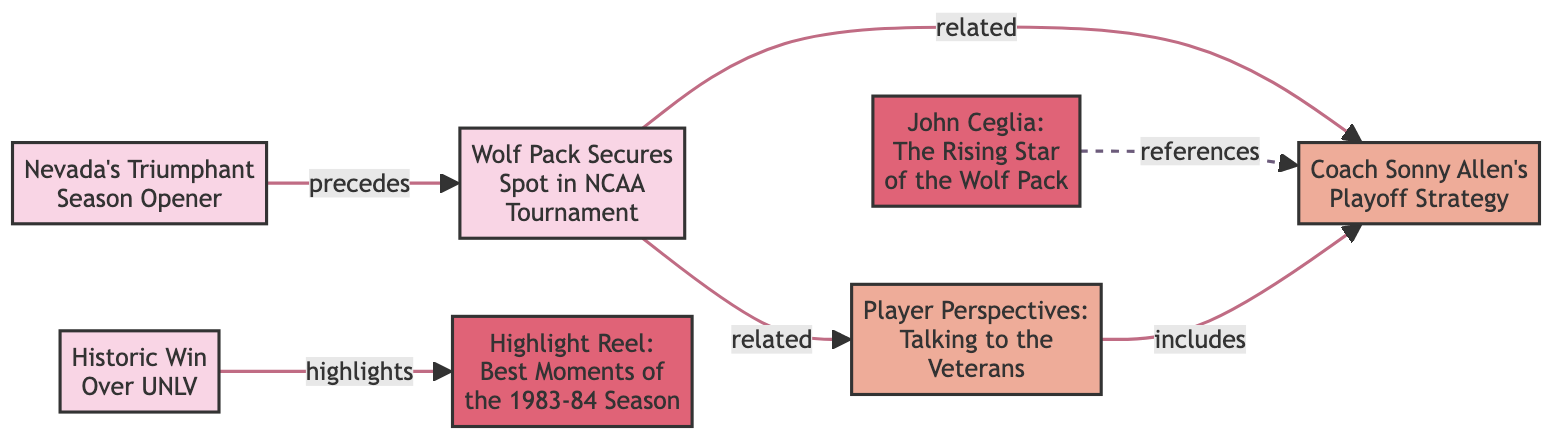What is the title of the feature related to John Ceglia? Looking at the diagram, the node labeled "John Ceglia: The Rising Star of the Wolf Pack" represents a feature. Therefore, this is the title of the feature connected to John Ceglia.
Answer: John Ceglia: The Rising Star of the Wolf Pack Which article precedes the one about the Wolf Pack's NCAA Tournament spot? The edge connecting the node for "Nevada's Triumphant Season Opener" (1) to "Wolf Pack Secures Spot in NCAA Tournament" (2) indicates a "precedes" relationship, meaning node 1 is the article before node 2.
Answer: Nevada's Triumphant Season Opener How many nodes are there in the diagram? Counting the number of nodes listed at the start, we see there are seven nodes in total: three articles, two features, and two interviews. Thus, the total count is seven.
Answer: 7 What type of media is "Coach Sonny Allen's Playoff Strategy"? The node labeled "Coach Sonny Allen's Playoff Strategy" (3) shows it is categorized under the "interview" type. Therefore, its media type is an interview.
Answer: interview Which article is highlighted by the historic win over UNLV? The edge from the node labeled "Historic Win Over UNLV" (5) to "Highlight Reel: Best Moments of the 1983-84 Season" (6) indicates that the historic win is a highlight of this season's best moments, meaning it highlights that specific feature.
Answer: Highlight Reel: Best Moments of the 1983-84 Season What is the relationship between the NCAA Tournament article and Player Perspectives interview? The diagram shows a "related" relationship between the node for "Wolf Pack Secures Spot in NCAA Tournament" (2) and the node for "Player Perspectives: Talking to the Veterans" (7). Therefore, these two nodes are related.
Answer: related Which interview includes aspects of Coach Sonny Allen's strategy? The edge from "Player Perspectives: Talking to the Veterans" (7) to "Coach Sonny Allen's Playoff Strategy" (3) specifies an "includes" relationship, indicating that the Player Perspectives interview covers topics related to Coach Sonny Allen's strategy.
Answer: Coach Sonny Allen's Playoff Strategy What is the publication date of the article on Nevada's season opener? The node for "Nevada's Triumphant Season Opener" (1) indicates that it was published on "1983-11-12." Therefore, that is its publication date.
Answer: 1983-11-12 